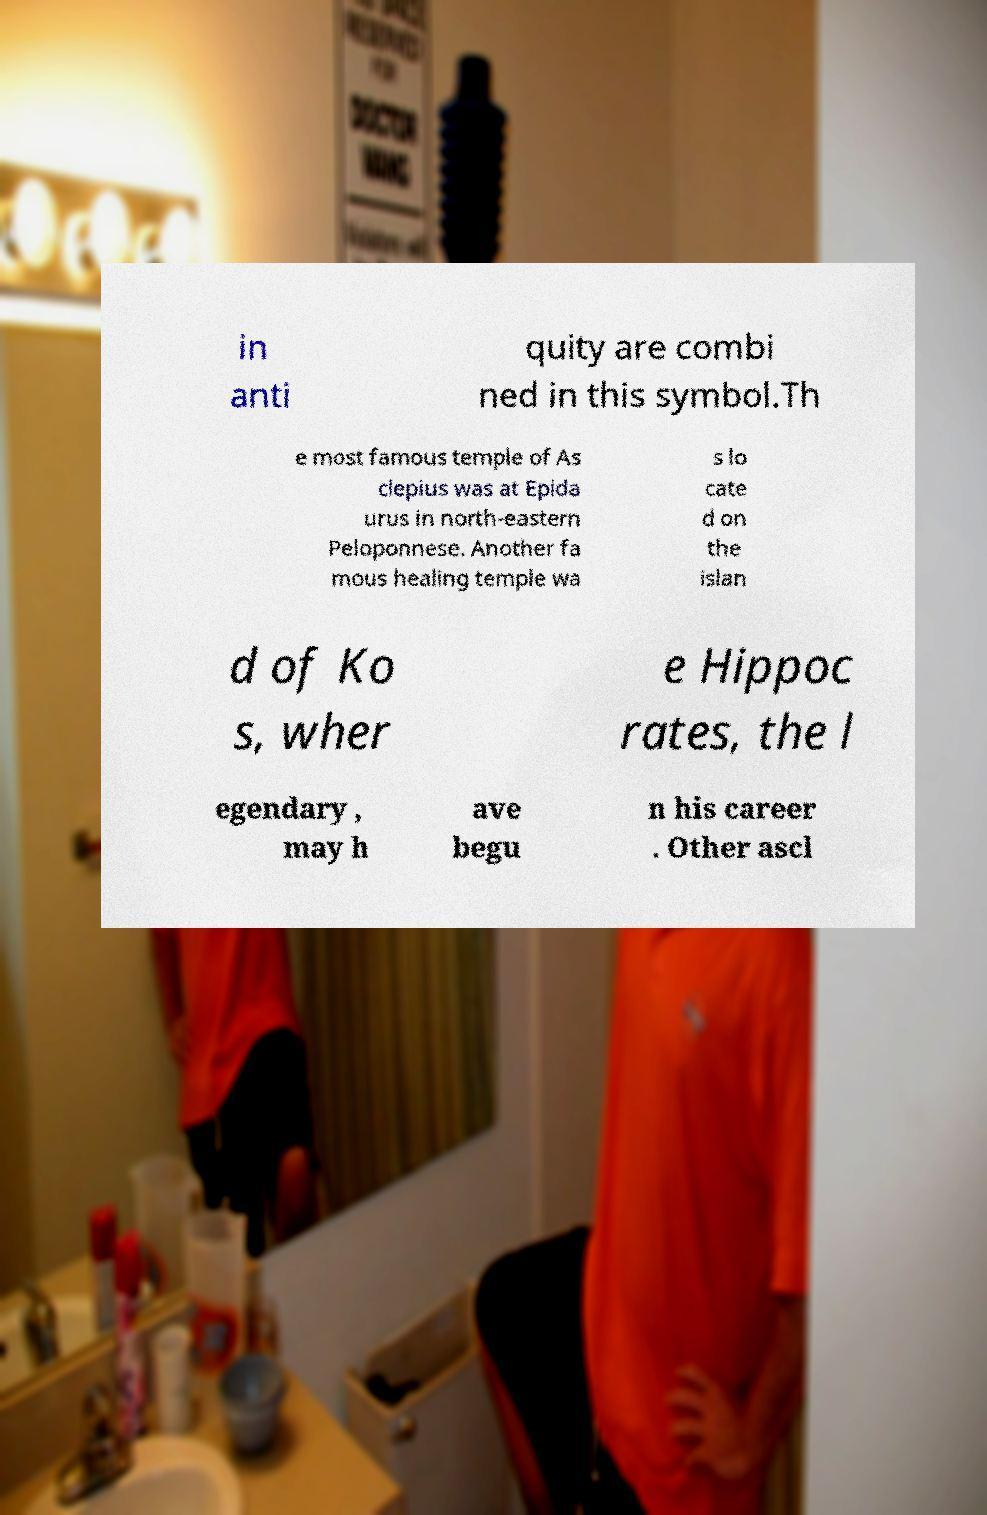There's text embedded in this image that I need extracted. Can you transcribe it verbatim? in anti quity are combi ned in this symbol.Th e most famous temple of As clepius was at Epida urus in north-eastern Peloponnese. Another fa mous healing temple wa s lo cate d on the islan d of Ko s, wher e Hippoc rates, the l egendary , may h ave begu n his career . Other ascl 